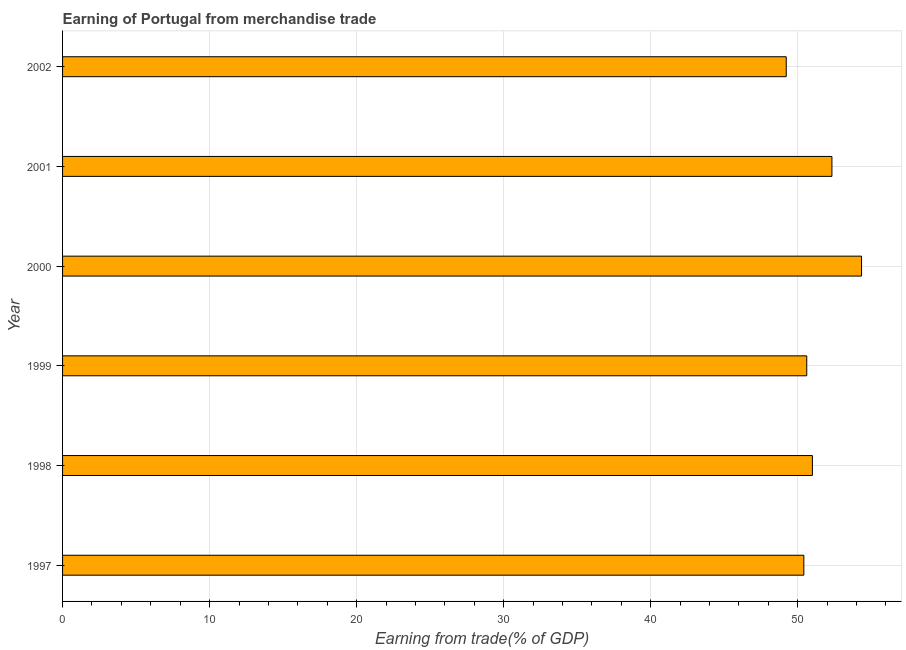What is the title of the graph?
Offer a very short reply. Earning of Portugal from merchandise trade. What is the label or title of the X-axis?
Provide a short and direct response. Earning from trade(% of GDP). What is the earning from merchandise trade in 2001?
Keep it short and to the point. 52.32. Across all years, what is the maximum earning from merchandise trade?
Provide a short and direct response. 54.34. Across all years, what is the minimum earning from merchandise trade?
Keep it short and to the point. 49.22. In which year was the earning from merchandise trade maximum?
Your answer should be compact. 2000. What is the sum of the earning from merchandise trade?
Your answer should be compact. 307.91. What is the difference between the earning from merchandise trade in 1999 and 2000?
Your answer should be very brief. -3.73. What is the average earning from merchandise trade per year?
Your answer should be very brief. 51.32. What is the median earning from merchandise trade?
Offer a terse response. 50.81. What is the ratio of the earning from merchandise trade in 2000 to that in 2001?
Your response must be concise. 1.04. What is the difference between the highest and the second highest earning from merchandise trade?
Make the answer very short. 2.02. What is the difference between the highest and the lowest earning from merchandise trade?
Keep it short and to the point. 5.12. In how many years, is the earning from merchandise trade greater than the average earning from merchandise trade taken over all years?
Your answer should be compact. 2. How many bars are there?
Make the answer very short. 6. Are all the bars in the graph horizontal?
Offer a terse response. Yes. Are the values on the major ticks of X-axis written in scientific E-notation?
Provide a succinct answer. No. What is the Earning from trade(% of GDP) in 1997?
Make the answer very short. 50.42. What is the Earning from trade(% of GDP) of 1998?
Your answer should be very brief. 51. What is the Earning from trade(% of GDP) of 1999?
Provide a short and direct response. 50.61. What is the Earning from trade(% of GDP) in 2000?
Provide a short and direct response. 54.34. What is the Earning from trade(% of GDP) in 2001?
Your answer should be compact. 52.32. What is the Earning from trade(% of GDP) in 2002?
Ensure brevity in your answer.  49.22. What is the difference between the Earning from trade(% of GDP) in 1997 and 1998?
Your answer should be compact. -0.58. What is the difference between the Earning from trade(% of GDP) in 1997 and 1999?
Give a very brief answer. -0.2. What is the difference between the Earning from trade(% of GDP) in 1997 and 2000?
Ensure brevity in your answer.  -3.92. What is the difference between the Earning from trade(% of GDP) in 1997 and 2001?
Your answer should be compact. -1.91. What is the difference between the Earning from trade(% of GDP) in 1997 and 2002?
Your response must be concise. 1.2. What is the difference between the Earning from trade(% of GDP) in 1998 and 1999?
Keep it short and to the point. 0.38. What is the difference between the Earning from trade(% of GDP) in 1998 and 2000?
Offer a very short reply. -3.34. What is the difference between the Earning from trade(% of GDP) in 1998 and 2001?
Your answer should be very brief. -1.33. What is the difference between the Earning from trade(% of GDP) in 1998 and 2002?
Offer a terse response. 1.78. What is the difference between the Earning from trade(% of GDP) in 1999 and 2000?
Your answer should be very brief. -3.73. What is the difference between the Earning from trade(% of GDP) in 1999 and 2001?
Offer a terse response. -1.71. What is the difference between the Earning from trade(% of GDP) in 1999 and 2002?
Keep it short and to the point. 1.4. What is the difference between the Earning from trade(% of GDP) in 2000 and 2001?
Keep it short and to the point. 2.02. What is the difference between the Earning from trade(% of GDP) in 2000 and 2002?
Make the answer very short. 5.12. What is the difference between the Earning from trade(% of GDP) in 2001 and 2002?
Offer a terse response. 3.11. What is the ratio of the Earning from trade(% of GDP) in 1997 to that in 1998?
Your answer should be compact. 0.99. What is the ratio of the Earning from trade(% of GDP) in 1997 to that in 2000?
Provide a succinct answer. 0.93. What is the ratio of the Earning from trade(% of GDP) in 1997 to that in 2001?
Provide a short and direct response. 0.96. What is the ratio of the Earning from trade(% of GDP) in 1998 to that in 2000?
Provide a short and direct response. 0.94. What is the ratio of the Earning from trade(% of GDP) in 1998 to that in 2001?
Ensure brevity in your answer.  0.97. What is the ratio of the Earning from trade(% of GDP) in 1998 to that in 2002?
Give a very brief answer. 1.04. What is the ratio of the Earning from trade(% of GDP) in 1999 to that in 2000?
Your answer should be very brief. 0.93. What is the ratio of the Earning from trade(% of GDP) in 1999 to that in 2001?
Your answer should be very brief. 0.97. What is the ratio of the Earning from trade(% of GDP) in 1999 to that in 2002?
Your response must be concise. 1.03. What is the ratio of the Earning from trade(% of GDP) in 2000 to that in 2001?
Your answer should be very brief. 1.04. What is the ratio of the Earning from trade(% of GDP) in 2000 to that in 2002?
Offer a terse response. 1.1. What is the ratio of the Earning from trade(% of GDP) in 2001 to that in 2002?
Offer a terse response. 1.06. 